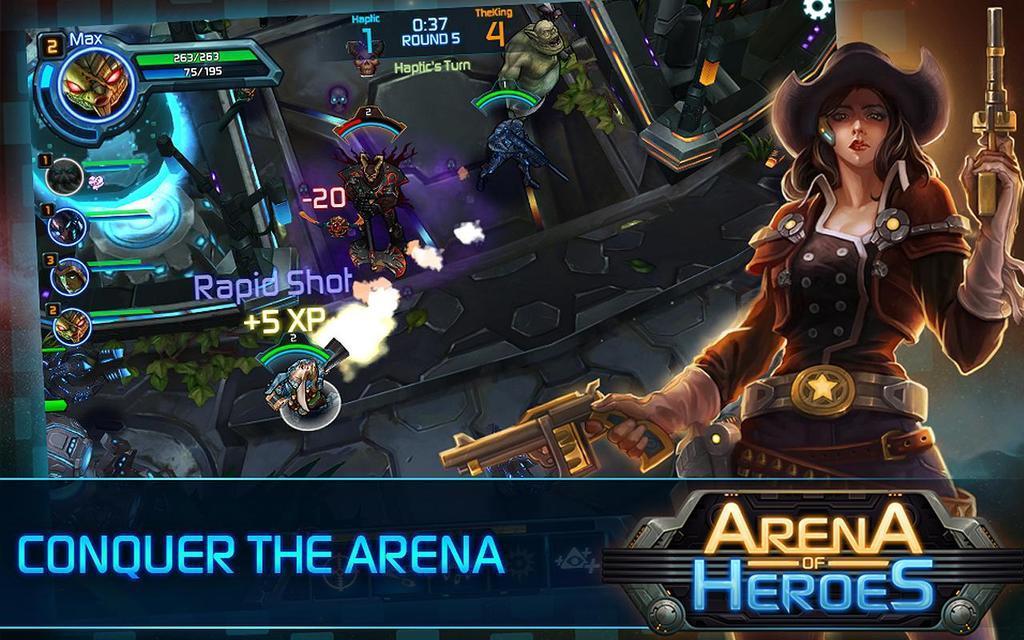Describe this image in one or two sentences. In this image we can see an animation of a lady and few objects. There is some text and logos in the image. 